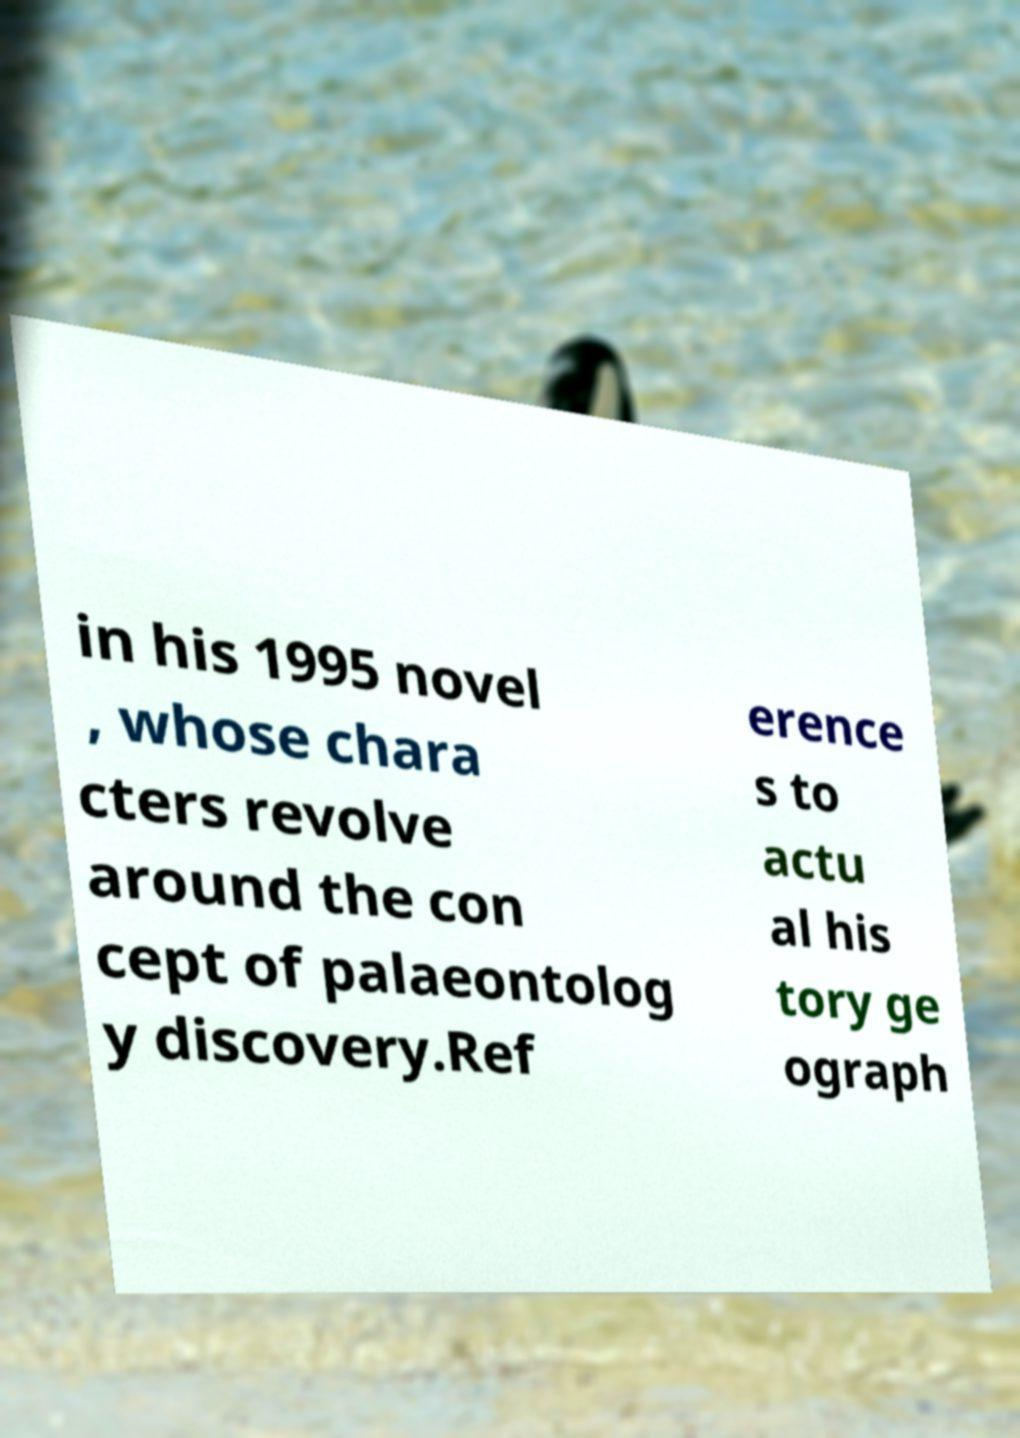Please read and relay the text visible in this image. What does it say? in his 1995 novel , whose chara cters revolve around the con cept of palaeontolog y discovery.Ref erence s to actu al his tory ge ograph 